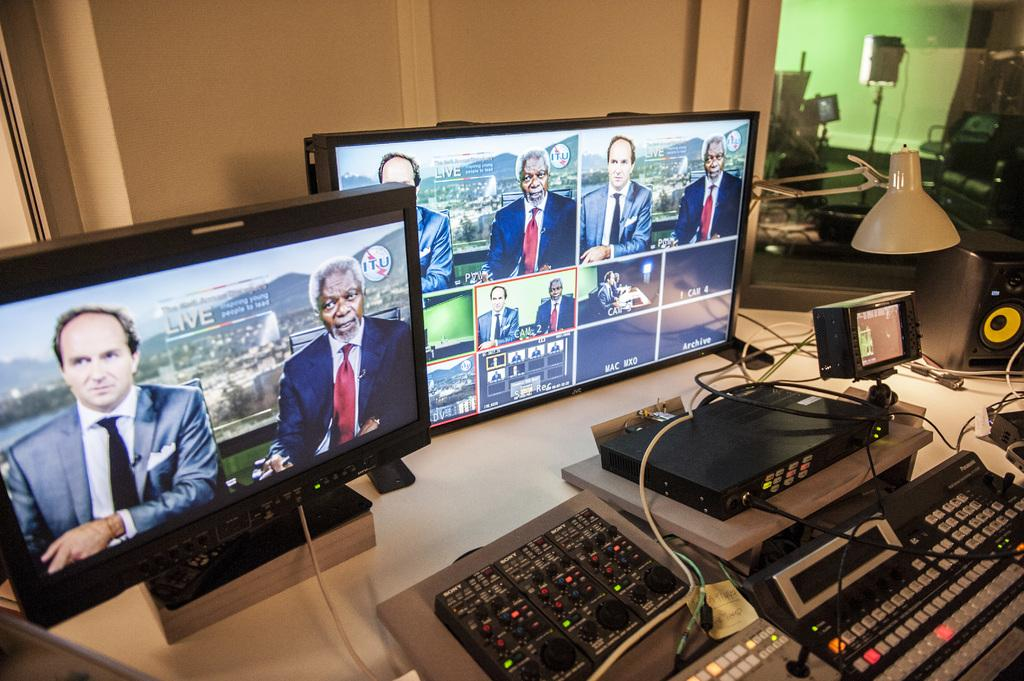<image>
Present a compact description of the photo's key features. Two monitors display various views of a Live broadcast. 